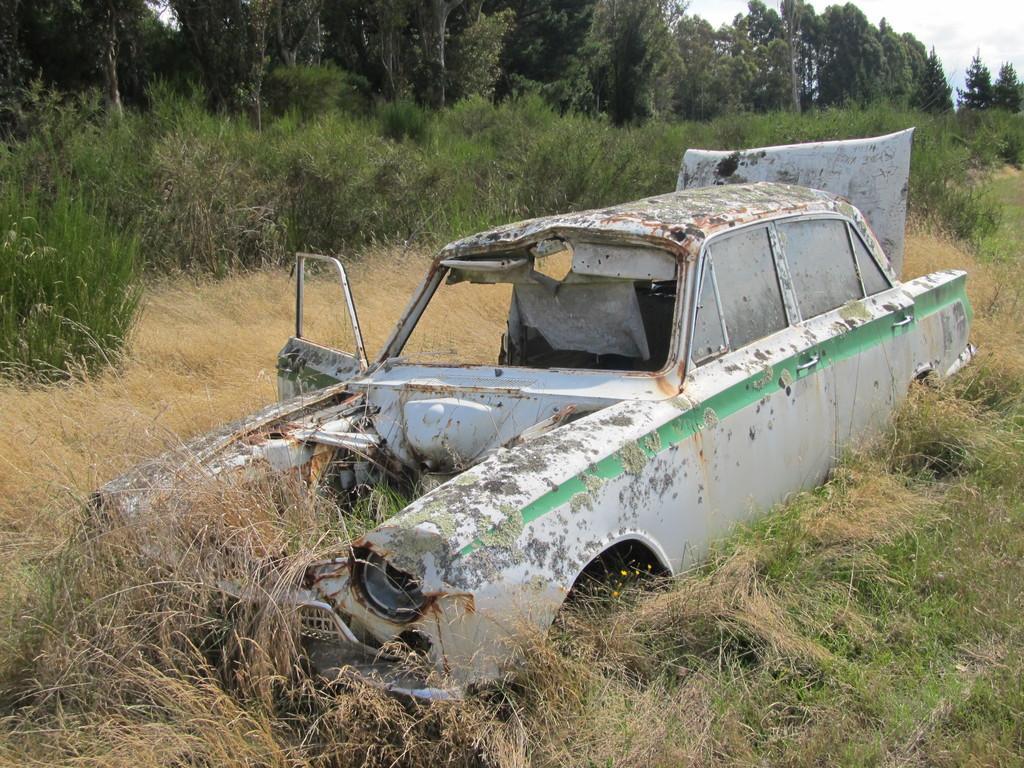In one or two sentences, can you explain what this image depicts? In this image there is one vehicle which is damaged, and at the bottom there is grass. And in the background there are some trees and plants. 